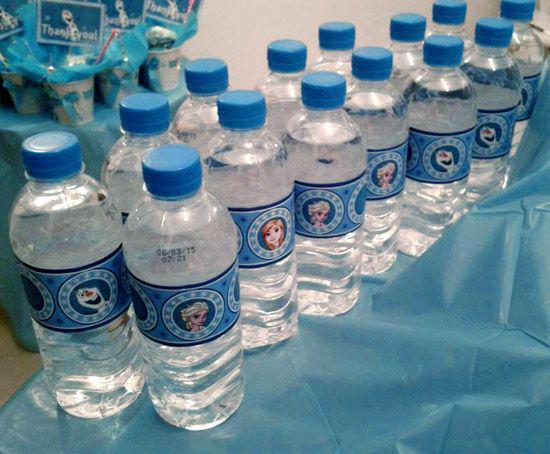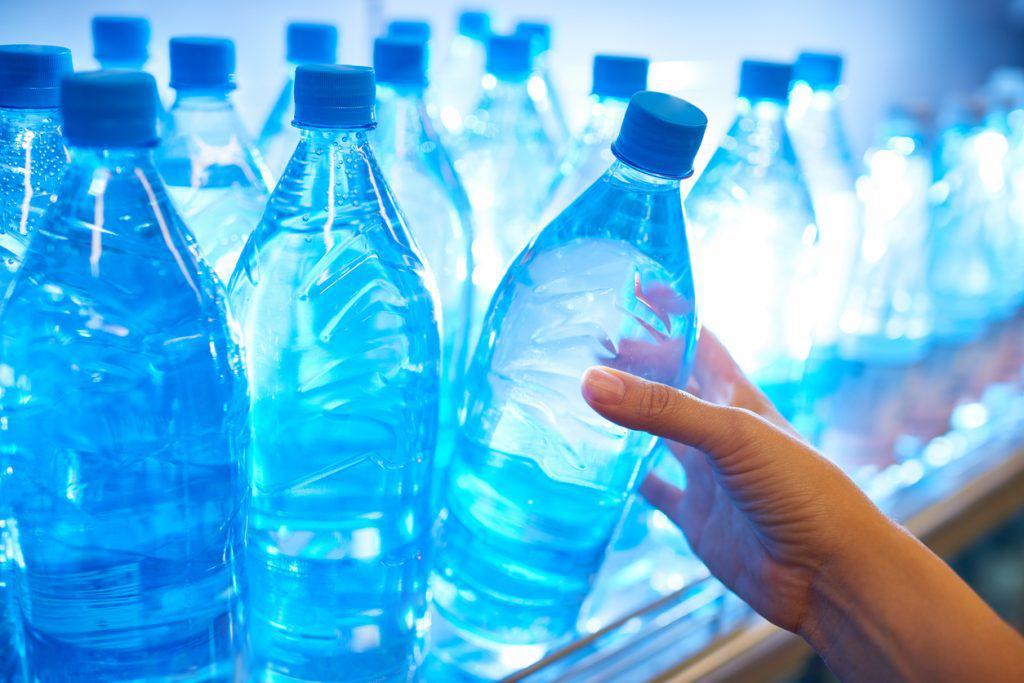The first image is the image on the left, the second image is the image on the right. For the images shown, is this caption "There is a variety of bottle in one of the images." true? Answer yes or no. No. 